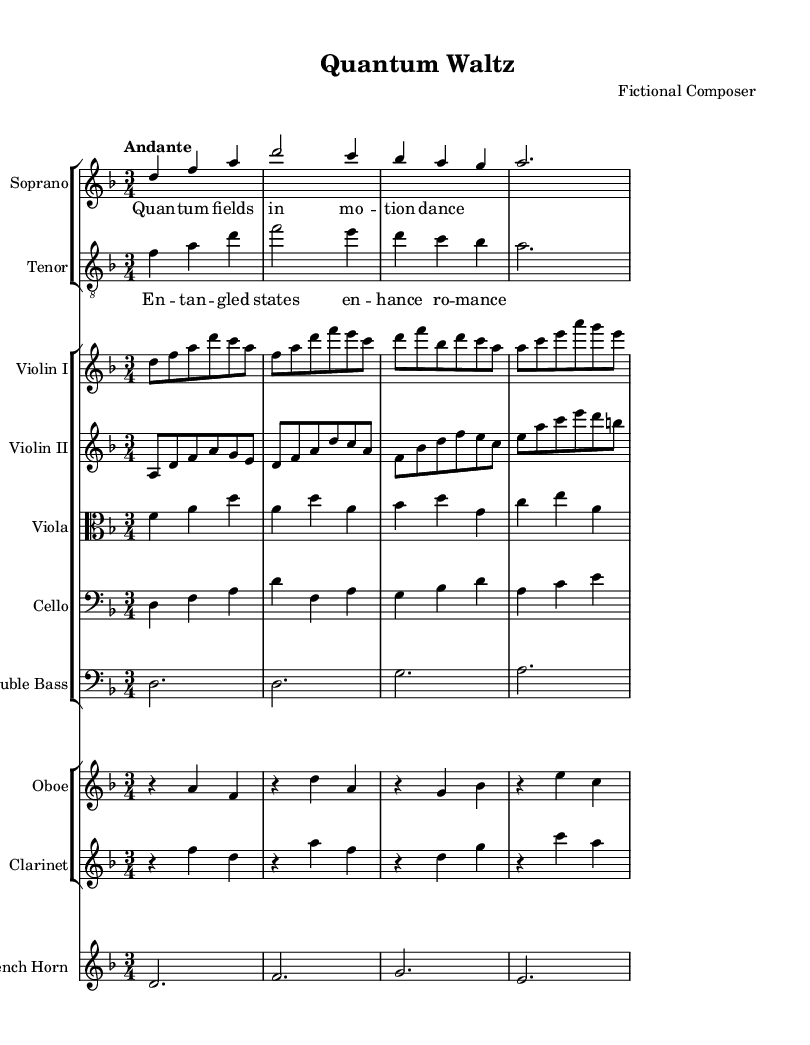What is the key signature of this music? The key signature is indicated at the beginning of the score. It shows two flats (B flat and E flat), which correspond to D minor.
Answer: D minor What is the time signature of this piece? The time signature appears at the beginning of the score, shown as 3/4, which means there are three beats in each measure.
Answer: 3/4 What is the tempo marking for this composition? The tempo is indicated at the beginning of the score with the word "Andante," which refers to a moderately slow tempo.
Answer: Andante How many measures are in the soprano voice? By counting the distinct groups of notes separated by vertical lines (bar lines) in the soprano voice notation, there are a total of 4 measures.
Answer: 4 What type of harmony is primarily used in this piece? The piece displays complex harmonies, visible through the interplay of voices and instruments, particularly within the contrasted lines of the soprano and tenor. The harmonic structure reflects polyphonic textures typical in operatic compositions.
Answer: Polyphonic How many vocal parts are present in this opera excerpt? In this piece, there are two vocal parts: Soprano and Tenor as indicated by their respective staves at the beginning of the score.
Answer: Two What is the significance of the text in the soprano lyrics? The lyrics refer to scientific themes, specifically quantum fields, indicating the thematic depth of the opera. The connection between the lyrics and the mathematical themes is a reflection of the opera's concept.
Answer: Quantum fields 